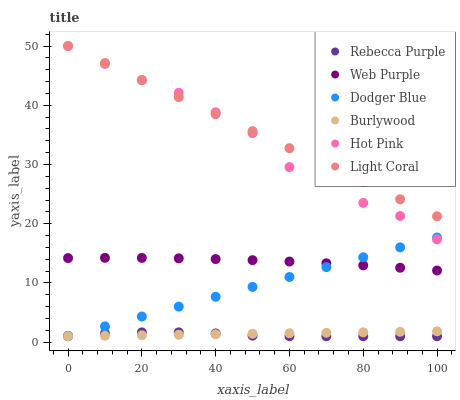Does Rebecca Purple have the minimum area under the curve?
Answer yes or no. Yes. Does Light Coral have the maximum area under the curve?
Answer yes or no. Yes. Does Hot Pink have the minimum area under the curve?
Answer yes or no. No. Does Hot Pink have the maximum area under the curve?
Answer yes or no. No. Is Burlywood the smoothest?
Answer yes or no. Yes. Is Hot Pink the roughest?
Answer yes or no. Yes. Is Light Coral the smoothest?
Answer yes or no. No. Is Light Coral the roughest?
Answer yes or no. No. Does Burlywood have the lowest value?
Answer yes or no. Yes. Does Hot Pink have the lowest value?
Answer yes or no. No. Does Light Coral have the highest value?
Answer yes or no. Yes. Does Web Purple have the highest value?
Answer yes or no. No. Is Rebecca Purple less than Light Coral?
Answer yes or no. Yes. Is Light Coral greater than Burlywood?
Answer yes or no. Yes. Does Hot Pink intersect Light Coral?
Answer yes or no. Yes. Is Hot Pink less than Light Coral?
Answer yes or no. No. Is Hot Pink greater than Light Coral?
Answer yes or no. No. Does Rebecca Purple intersect Light Coral?
Answer yes or no. No. 